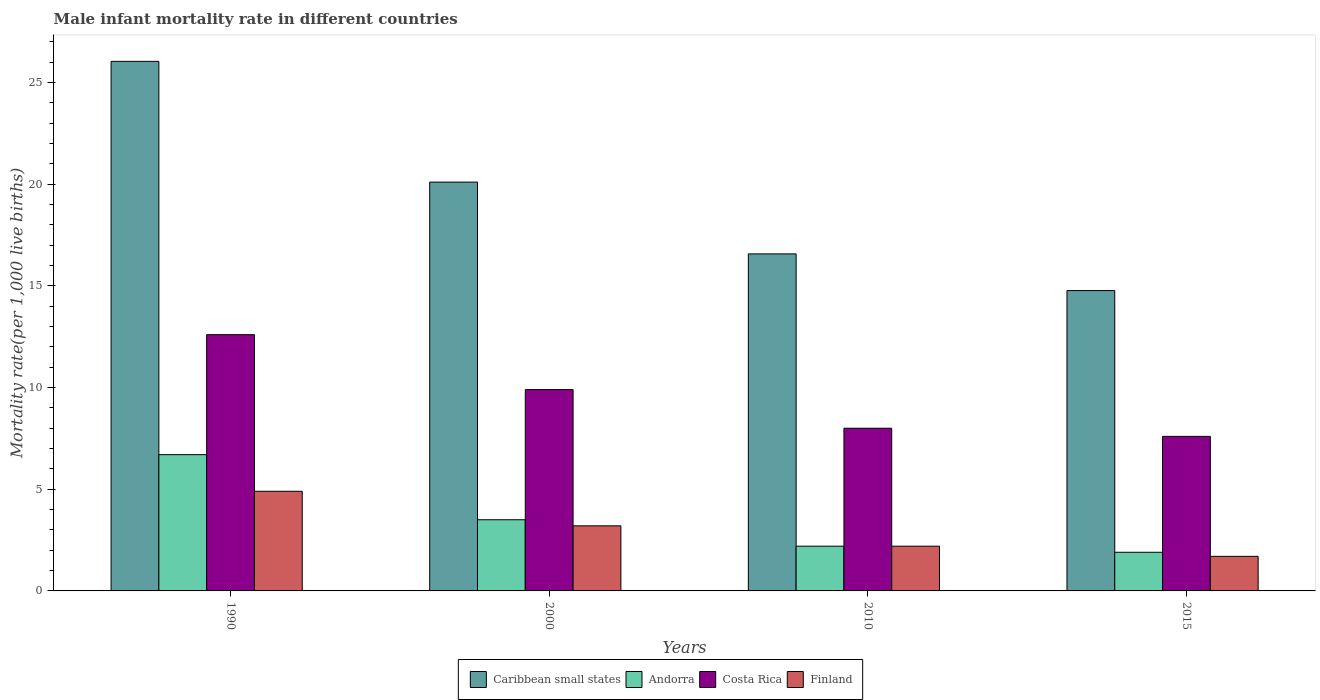How many different coloured bars are there?
Ensure brevity in your answer.  4. How many groups of bars are there?
Make the answer very short. 4. Are the number of bars per tick equal to the number of legend labels?
Your answer should be very brief. Yes. How many bars are there on the 4th tick from the right?
Provide a succinct answer. 4. What is the male infant mortality rate in Andorra in 2000?
Your response must be concise. 3.5. Across all years, what is the maximum male infant mortality rate in Caribbean small states?
Offer a terse response. 26.04. Across all years, what is the minimum male infant mortality rate in Costa Rica?
Your response must be concise. 7.6. In which year was the male infant mortality rate in Andorra maximum?
Give a very brief answer. 1990. In which year was the male infant mortality rate in Costa Rica minimum?
Your response must be concise. 2015. What is the total male infant mortality rate in Andorra in the graph?
Your answer should be compact. 14.3. What is the difference between the male infant mortality rate in Andorra in 1990 and that in 2015?
Your answer should be compact. 4.8. What is the difference between the male infant mortality rate in Caribbean small states in 2000 and the male infant mortality rate in Andorra in 2010?
Provide a short and direct response. 17.9. What is the average male infant mortality rate in Costa Rica per year?
Provide a succinct answer. 9.53. In the year 2010, what is the difference between the male infant mortality rate in Caribbean small states and male infant mortality rate in Costa Rica?
Keep it short and to the point. 8.57. In how many years, is the male infant mortality rate in Finland greater than 5?
Ensure brevity in your answer.  0. What is the ratio of the male infant mortality rate in Finland in 1990 to that in 2015?
Provide a succinct answer. 2.88. What is the difference between the highest and the second highest male infant mortality rate in Costa Rica?
Offer a very short reply. 2.7. What is the difference between the highest and the lowest male infant mortality rate in Finland?
Offer a terse response. 3.2. Is the sum of the male infant mortality rate in Caribbean small states in 1990 and 2000 greater than the maximum male infant mortality rate in Finland across all years?
Your answer should be very brief. Yes. What does the 2nd bar from the right in 2000 represents?
Your answer should be compact. Costa Rica. How many bars are there?
Provide a succinct answer. 16. Are all the bars in the graph horizontal?
Provide a short and direct response. No. How many years are there in the graph?
Offer a very short reply. 4. What is the difference between two consecutive major ticks on the Y-axis?
Offer a very short reply. 5. Does the graph contain grids?
Offer a terse response. No. Where does the legend appear in the graph?
Ensure brevity in your answer.  Bottom center. How many legend labels are there?
Give a very brief answer. 4. How are the legend labels stacked?
Ensure brevity in your answer.  Horizontal. What is the title of the graph?
Your answer should be very brief. Male infant mortality rate in different countries. Does "Swaziland" appear as one of the legend labels in the graph?
Your answer should be compact. No. What is the label or title of the X-axis?
Keep it short and to the point. Years. What is the label or title of the Y-axis?
Your answer should be compact. Mortality rate(per 1,0 live births). What is the Mortality rate(per 1,000 live births) in Caribbean small states in 1990?
Ensure brevity in your answer.  26.04. What is the Mortality rate(per 1,000 live births) in Costa Rica in 1990?
Offer a terse response. 12.6. What is the Mortality rate(per 1,000 live births) in Caribbean small states in 2000?
Your answer should be very brief. 20.1. What is the Mortality rate(per 1,000 live births) of Andorra in 2000?
Offer a terse response. 3.5. What is the Mortality rate(per 1,000 live births) in Finland in 2000?
Make the answer very short. 3.2. What is the Mortality rate(per 1,000 live births) in Caribbean small states in 2010?
Ensure brevity in your answer.  16.57. What is the Mortality rate(per 1,000 live births) in Andorra in 2010?
Offer a very short reply. 2.2. What is the Mortality rate(per 1,000 live births) in Caribbean small states in 2015?
Give a very brief answer. 14.77. What is the Mortality rate(per 1,000 live births) in Andorra in 2015?
Offer a very short reply. 1.9. What is the Mortality rate(per 1,000 live births) in Costa Rica in 2015?
Make the answer very short. 7.6. What is the Mortality rate(per 1,000 live births) of Finland in 2015?
Your answer should be compact. 1.7. Across all years, what is the maximum Mortality rate(per 1,000 live births) of Caribbean small states?
Ensure brevity in your answer.  26.04. Across all years, what is the maximum Mortality rate(per 1,000 live births) in Andorra?
Keep it short and to the point. 6.7. Across all years, what is the maximum Mortality rate(per 1,000 live births) in Costa Rica?
Your response must be concise. 12.6. Across all years, what is the maximum Mortality rate(per 1,000 live births) of Finland?
Your answer should be compact. 4.9. Across all years, what is the minimum Mortality rate(per 1,000 live births) of Caribbean small states?
Give a very brief answer. 14.77. Across all years, what is the minimum Mortality rate(per 1,000 live births) in Finland?
Keep it short and to the point. 1.7. What is the total Mortality rate(per 1,000 live births) of Caribbean small states in the graph?
Provide a succinct answer. 77.48. What is the total Mortality rate(per 1,000 live births) in Andorra in the graph?
Keep it short and to the point. 14.3. What is the total Mortality rate(per 1,000 live births) of Costa Rica in the graph?
Give a very brief answer. 38.1. What is the difference between the Mortality rate(per 1,000 live births) in Caribbean small states in 1990 and that in 2000?
Keep it short and to the point. 5.94. What is the difference between the Mortality rate(per 1,000 live births) of Andorra in 1990 and that in 2000?
Ensure brevity in your answer.  3.2. What is the difference between the Mortality rate(per 1,000 live births) in Caribbean small states in 1990 and that in 2010?
Give a very brief answer. 9.47. What is the difference between the Mortality rate(per 1,000 live births) of Caribbean small states in 1990 and that in 2015?
Provide a succinct answer. 11.27. What is the difference between the Mortality rate(per 1,000 live births) in Finland in 1990 and that in 2015?
Make the answer very short. 3.2. What is the difference between the Mortality rate(per 1,000 live births) of Caribbean small states in 2000 and that in 2010?
Your answer should be compact. 3.53. What is the difference between the Mortality rate(per 1,000 live births) of Caribbean small states in 2000 and that in 2015?
Ensure brevity in your answer.  5.33. What is the difference between the Mortality rate(per 1,000 live births) in Andorra in 2000 and that in 2015?
Provide a short and direct response. 1.6. What is the difference between the Mortality rate(per 1,000 live births) of Finland in 2000 and that in 2015?
Give a very brief answer. 1.5. What is the difference between the Mortality rate(per 1,000 live births) of Caribbean small states in 2010 and that in 2015?
Offer a terse response. 1.8. What is the difference between the Mortality rate(per 1,000 live births) in Andorra in 2010 and that in 2015?
Offer a very short reply. 0.3. What is the difference between the Mortality rate(per 1,000 live births) in Finland in 2010 and that in 2015?
Make the answer very short. 0.5. What is the difference between the Mortality rate(per 1,000 live births) of Caribbean small states in 1990 and the Mortality rate(per 1,000 live births) of Andorra in 2000?
Make the answer very short. 22.54. What is the difference between the Mortality rate(per 1,000 live births) in Caribbean small states in 1990 and the Mortality rate(per 1,000 live births) in Costa Rica in 2000?
Offer a terse response. 16.14. What is the difference between the Mortality rate(per 1,000 live births) of Caribbean small states in 1990 and the Mortality rate(per 1,000 live births) of Finland in 2000?
Give a very brief answer. 22.84. What is the difference between the Mortality rate(per 1,000 live births) of Andorra in 1990 and the Mortality rate(per 1,000 live births) of Costa Rica in 2000?
Your answer should be very brief. -3.2. What is the difference between the Mortality rate(per 1,000 live births) of Andorra in 1990 and the Mortality rate(per 1,000 live births) of Finland in 2000?
Your answer should be compact. 3.5. What is the difference between the Mortality rate(per 1,000 live births) of Caribbean small states in 1990 and the Mortality rate(per 1,000 live births) of Andorra in 2010?
Ensure brevity in your answer.  23.84. What is the difference between the Mortality rate(per 1,000 live births) in Caribbean small states in 1990 and the Mortality rate(per 1,000 live births) in Costa Rica in 2010?
Make the answer very short. 18.04. What is the difference between the Mortality rate(per 1,000 live births) of Caribbean small states in 1990 and the Mortality rate(per 1,000 live births) of Finland in 2010?
Keep it short and to the point. 23.84. What is the difference between the Mortality rate(per 1,000 live births) in Caribbean small states in 1990 and the Mortality rate(per 1,000 live births) in Andorra in 2015?
Ensure brevity in your answer.  24.14. What is the difference between the Mortality rate(per 1,000 live births) of Caribbean small states in 1990 and the Mortality rate(per 1,000 live births) of Costa Rica in 2015?
Your answer should be compact. 18.44. What is the difference between the Mortality rate(per 1,000 live births) in Caribbean small states in 1990 and the Mortality rate(per 1,000 live births) in Finland in 2015?
Give a very brief answer. 24.34. What is the difference between the Mortality rate(per 1,000 live births) in Caribbean small states in 2000 and the Mortality rate(per 1,000 live births) in Andorra in 2010?
Ensure brevity in your answer.  17.9. What is the difference between the Mortality rate(per 1,000 live births) in Caribbean small states in 2000 and the Mortality rate(per 1,000 live births) in Costa Rica in 2010?
Offer a very short reply. 12.1. What is the difference between the Mortality rate(per 1,000 live births) of Caribbean small states in 2000 and the Mortality rate(per 1,000 live births) of Finland in 2010?
Make the answer very short. 17.9. What is the difference between the Mortality rate(per 1,000 live births) in Andorra in 2000 and the Mortality rate(per 1,000 live births) in Costa Rica in 2010?
Provide a succinct answer. -4.5. What is the difference between the Mortality rate(per 1,000 live births) in Costa Rica in 2000 and the Mortality rate(per 1,000 live births) in Finland in 2010?
Your answer should be very brief. 7.7. What is the difference between the Mortality rate(per 1,000 live births) of Caribbean small states in 2000 and the Mortality rate(per 1,000 live births) of Andorra in 2015?
Make the answer very short. 18.2. What is the difference between the Mortality rate(per 1,000 live births) in Caribbean small states in 2000 and the Mortality rate(per 1,000 live births) in Costa Rica in 2015?
Your response must be concise. 12.5. What is the difference between the Mortality rate(per 1,000 live births) of Caribbean small states in 2000 and the Mortality rate(per 1,000 live births) of Finland in 2015?
Your answer should be very brief. 18.4. What is the difference between the Mortality rate(per 1,000 live births) of Andorra in 2000 and the Mortality rate(per 1,000 live births) of Costa Rica in 2015?
Ensure brevity in your answer.  -4.1. What is the difference between the Mortality rate(per 1,000 live births) in Caribbean small states in 2010 and the Mortality rate(per 1,000 live births) in Andorra in 2015?
Offer a very short reply. 14.67. What is the difference between the Mortality rate(per 1,000 live births) of Caribbean small states in 2010 and the Mortality rate(per 1,000 live births) of Costa Rica in 2015?
Make the answer very short. 8.97. What is the difference between the Mortality rate(per 1,000 live births) of Caribbean small states in 2010 and the Mortality rate(per 1,000 live births) of Finland in 2015?
Your answer should be compact. 14.87. What is the difference between the Mortality rate(per 1,000 live births) in Andorra in 2010 and the Mortality rate(per 1,000 live births) in Costa Rica in 2015?
Your answer should be very brief. -5.4. What is the average Mortality rate(per 1,000 live births) of Caribbean small states per year?
Keep it short and to the point. 19.37. What is the average Mortality rate(per 1,000 live births) of Andorra per year?
Provide a short and direct response. 3.58. What is the average Mortality rate(per 1,000 live births) in Costa Rica per year?
Ensure brevity in your answer.  9.53. In the year 1990, what is the difference between the Mortality rate(per 1,000 live births) of Caribbean small states and Mortality rate(per 1,000 live births) of Andorra?
Ensure brevity in your answer.  19.34. In the year 1990, what is the difference between the Mortality rate(per 1,000 live births) in Caribbean small states and Mortality rate(per 1,000 live births) in Costa Rica?
Offer a very short reply. 13.44. In the year 1990, what is the difference between the Mortality rate(per 1,000 live births) of Caribbean small states and Mortality rate(per 1,000 live births) of Finland?
Offer a terse response. 21.14. In the year 1990, what is the difference between the Mortality rate(per 1,000 live births) in Andorra and Mortality rate(per 1,000 live births) in Costa Rica?
Make the answer very short. -5.9. In the year 1990, what is the difference between the Mortality rate(per 1,000 live births) in Andorra and Mortality rate(per 1,000 live births) in Finland?
Give a very brief answer. 1.8. In the year 2000, what is the difference between the Mortality rate(per 1,000 live births) in Caribbean small states and Mortality rate(per 1,000 live births) in Andorra?
Ensure brevity in your answer.  16.6. In the year 2000, what is the difference between the Mortality rate(per 1,000 live births) of Caribbean small states and Mortality rate(per 1,000 live births) of Costa Rica?
Make the answer very short. 10.2. In the year 2000, what is the difference between the Mortality rate(per 1,000 live births) in Caribbean small states and Mortality rate(per 1,000 live births) in Finland?
Your answer should be compact. 16.9. In the year 2000, what is the difference between the Mortality rate(per 1,000 live births) of Andorra and Mortality rate(per 1,000 live births) of Costa Rica?
Your response must be concise. -6.4. In the year 2000, what is the difference between the Mortality rate(per 1,000 live births) of Andorra and Mortality rate(per 1,000 live births) of Finland?
Make the answer very short. 0.3. In the year 2010, what is the difference between the Mortality rate(per 1,000 live births) of Caribbean small states and Mortality rate(per 1,000 live births) of Andorra?
Ensure brevity in your answer.  14.37. In the year 2010, what is the difference between the Mortality rate(per 1,000 live births) of Caribbean small states and Mortality rate(per 1,000 live births) of Costa Rica?
Offer a terse response. 8.57. In the year 2010, what is the difference between the Mortality rate(per 1,000 live births) of Caribbean small states and Mortality rate(per 1,000 live births) of Finland?
Keep it short and to the point. 14.37. In the year 2010, what is the difference between the Mortality rate(per 1,000 live births) of Costa Rica and Mortality rate(per 1,000 live births) of Finland?
Keep it short and to the point. 5.8. In the year 2015, what is the difference between the Mortality rate(per 1,000 live births) in Caribbean small states and Mortality rate(per 1,000 live births) in Andorra?
Keep it short and to the point. 12.87. In the year 2015, what is the difference between the Mortality rate(per 1,000 live births) of Caribbean small states and Mortality rate(per 1,000 live births) of Costa Rica?
Ensure brevity in your answer.  7.17. In the year 2015, what is the difference between the Mortality rate(per 1,000 live births) in Caribbean small states and Mortality rate(per 1,000 live births) in Finland?
Your answer should be very brief. 13.07. In the year 2015, what is the difference between the Mortality rate(per 1,000 live births) in Costa Rica and Mortality rate(per 1,000 live births) in Finland?
Ensure brevity in your answer.  5.9. What is the ratio of the Mortality rate(per 1,000 live births) of Caribbean small states in 1990 to that in 2000?
Offer a very short reply. 1.3. What is the ratio of the Mortality rate(per 1,000 live births) in Andorra in 1990 to that in 2000?
Keep it short and to the point. 1.91. What is the ratio of the Mortality rate(per 1,000 live births) of Costa Rica in 1990 to that in 2000?
Give a very brief answer. 1.27. What is the ratio of the Mortality rate(per 1,000 live births) of Finland in 1990 to that in 2000?
Provide a short and direct response. 1.53. What is the ratio of the Mortality rate(per 1,000 live births) of Caribbean small states in 1990 to that in 2010?
Offer a very short reply. 1.57. What is the ratio of the Mortality rate(per 1,000 live births) in Andorra in 1990 to that in 2010?
Your answer should be very brief. 3.05. What is the ratio of the Mortality rate(per 1,000 live births) of Costa Rica in 1990 to that in 2010?
Your answer should be compact. 1.57. What is the ratio of the Mortality rate(per 1,000 live births) of Finland in 1990 to that in 2010?
Provide a succinct answer. 2.23. What is the ratio of the Mortality rate(per 1,000 live births) of Caribbean small states in 1990 to that in 2015?
Your answer should be very brief. 1.76. What is the ratio of the Mortality rate(per 1,000 live births) of Andorra in 1990 to that in 2015?
Give a very brief answer. 3.53. What is the ratio of the Mortality rate(per 1,000 live births) in Costa Rica in 1990 to that in 2015?
Keep it short and to the point. 1.66. What is the ratio of the Mortality rate(per 1,000 live births) in Finland in 1990 to that in 2015?
Your answer should be very brief. 2.88. What is the ratio of the Mortality rate(per 1,000 live births) in Caribbean small states in 2000 to that in 2010?
Your answer should be compact. 1.21. What is the ratio of the Mortality rate(per 1,000 live births) in Andorra in 2000 to that in 2010?
Make the answer very short. 1.59. What is the ratio of the Mortality rate(per 1,000 live births) of Costa Rica in 2000 to that in 2010?
Provide a short and direct response. 1.24. What is the ratio of the Mortality rate(per 1,000 live births) of Finland in 2000 to that in 2010?
Offer a very short reply. 1.45. What is the ratio of the Mortality rate(per 1,000 live births) of Caribbean small states in 2000 to that in 2015?
Your answer should be very brief. 1.36. What is the ratio of the Mortality rate(per 1,000 live births) in Andorra in 2000 to that in 2015?
Make the answer very short. 1.84. What is the ratio of the Mortality rate(per 1,000 live births) in Costa Rica in 2000 to that in 2015?
Your answer should be compact. 1.3. What is the ratio of the Mortality rate(per 1,000 live births) of Finland in 2000 to that in 2015?
Offer a terse response. 1.88. What is the ratio of the Mortality rate(per 1,000 live births) in Caribbean small states in 2010 to that in 2015?
Offer a terse response. 1.12. What is the ratio of the Mortality rate(per 1,000 live births) in Andorra in 2010 to that in 2015?
Your response must be concise. 1.16. What is the ratio of the Mortality rate(per 1,000 live births) of Costa Rica in 2010 to that in 2015?
Offer a terse response. 1.05. What is the ratio of the Mortality rate(per 1,000 live births) of Finland in 2010 to that in 2015?
Offer a terse response. 1.29. What is the difference between the highest and the second highest Mortality rate(per 1,000 live births) of Caribbean small states?
Keep it short and to the point. 5.94. What is the difference between the highest and the second highest Mortality rate(per 1,000 live births) in Finland?
Give a very brief answer. 1.7. What is the difference between the highest and the lowest Mortality rate(per 1,000 live births) of Caribbean small states?
Provide a succinct answer. 11.27. What is the difference between the highest and the lowest Mortality rate(per 1,000 live births) in Andorra?
Keep it short and to the point. 4.8. What is the difference between the highest and the lowest Mortality rate(per 1,000 live births) in Finland?
Ensure brevity in your answer.  3.2. 